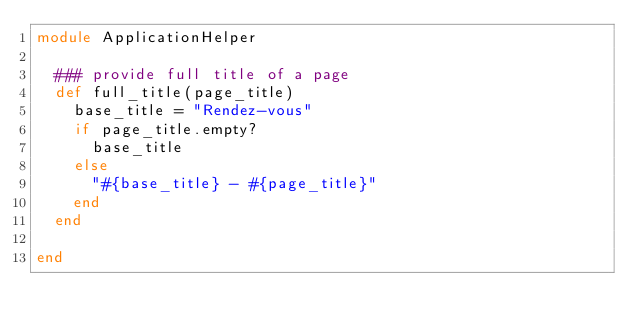Convert code to text. <code><loc_0><loc_0><loc_500><loc_500><_Ruby_>module ApplicationHelper
  
  ### provide full title of a page
  def full_title(page_title)
    base_title = "Rendez-vous"
    if page_title.empty?
      base_title
    else
      "#{base_title} - #{page_title}"
    end
  end
  
end
</code> 